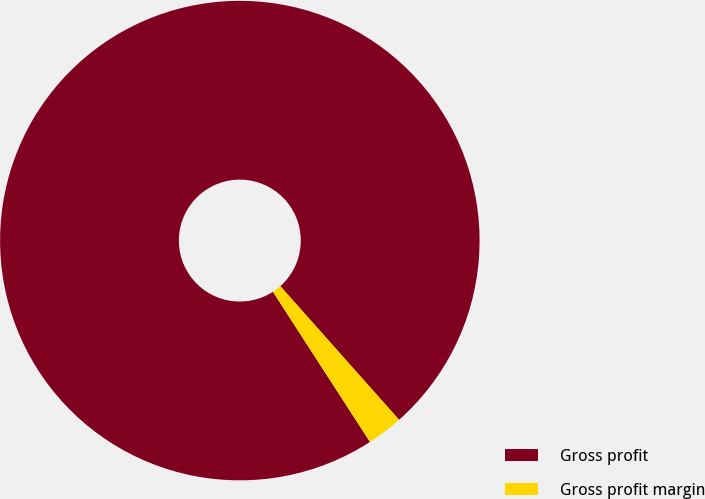Convert chart to OTSL. <chart><loc_0><loc_0><loc_500><loc_500><pie_chart><fcel>Gross profit<fcel>Gross profit margin<nl><fcel>97.57%<fcel>2.43%<nl></chart> 